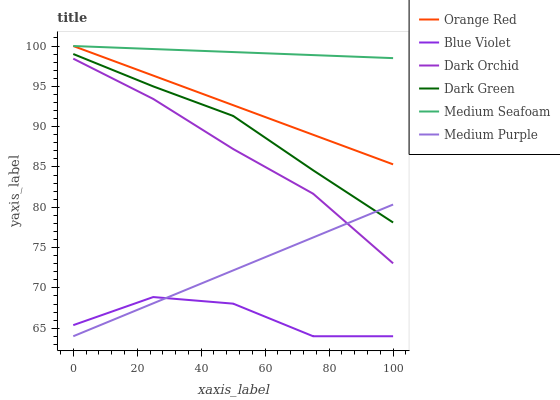Does Blue Violet have the minimum area under the curve?
Answer yes or no. Yes. Does Medium Seafoam have the maximum area under the curve?
Answer yes or no. Yes. Does Orange Red have the minimum area under the curve?
Answer yes or no. No. Does Orange Red have the maximum area under the curve?
Answer yes or no. No. Is Medium Purple the smoothest?
Answer yes or no. Yes. Is Blue Violet the roughest?
Answer yes or no. Yes. Is Orange Red the smoothest?
Answer yes or no. No. Is Orange Red the roughest?
Answer yes or no. No. Does Orange Red have the lowest value?
Answer yes or no. No. Does Medium Seafoam have the highest value?
Answer yes or no. Yes. Does Medium Purple have the highest value?
Answer yes or no. No. Is Dark Orchid less than Medium Seafoam?
Answer yes or no. Yes. Is Orange Red greater than Dark Orchid?
Answer yes or no. Yes. Does Orange Red intersect Medium Seafoam?
Answer yes or no. Yes. Is Orange Red less than Medium Seafoam?
Answer yes or no. No. Is Orange Red greater than Medium Seafoam?
Answer yes or no. No. Does Dark Orchid intersect Medium Seafoam?
Answer yes or no. No. 